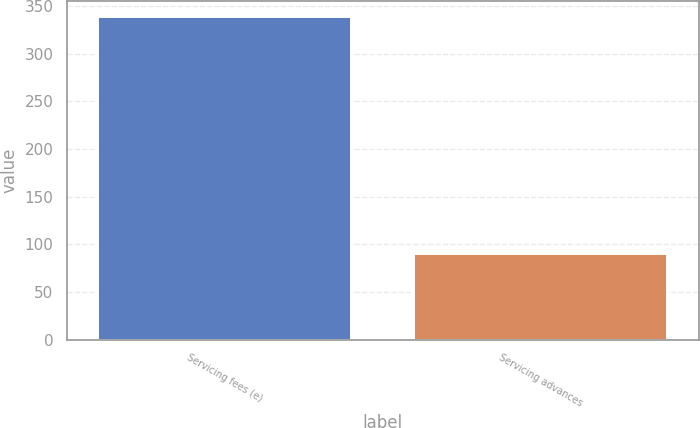Convert chart to OTSL. <chart><loc_0><loc_0><loc_500><loc_500><bar_chart><fcel>Servicing fees (e)<fcel>Servicing advances<nl><fcel>339<fcel>90<nl></chart> 